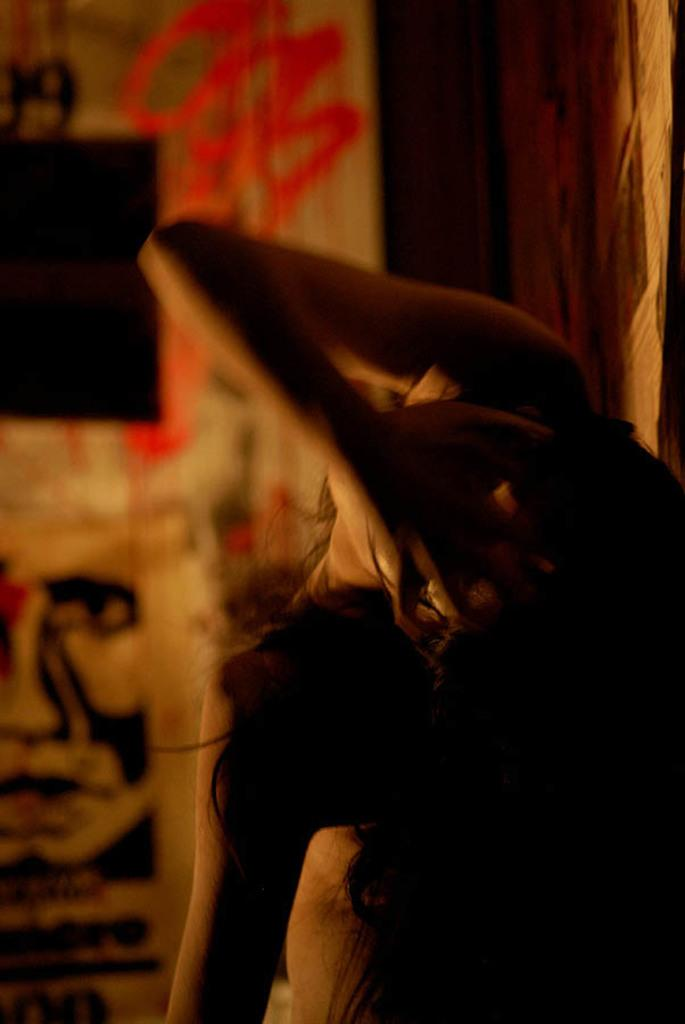Who is present in the image? There is a woman in the image. What can be seen in the background of the image? There is a painted wall in the background of the image. What type of zephyr can be seen interacting with the woman in the image? There is no zephyr present in the image, as zephyrs are gentle breezes and not visible entities. 